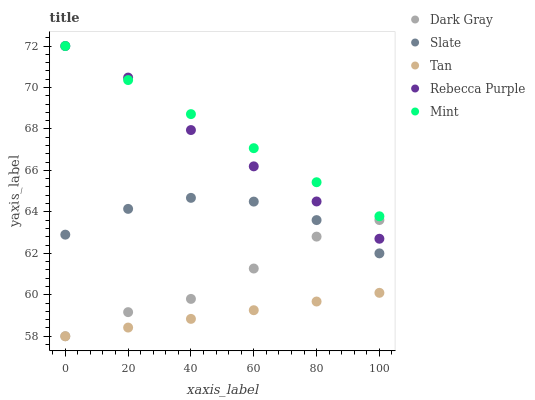Does Tan have the minimum area under the curve?
Answer yes or no. Yes. Does Mint have the maximum area under the curve?
Answer yes or no. Yes. Does Slate have the minimum area under the curve?
Answer yes or no. No. Does Slate have the maximum area under the curve?
Answer yes or no. No. Is Tan the smoothest?
Answer yes or no. Yes. Is Slate the roughest?
Answer yes or no. Yes. Is Mint the smoothest?
Answer yes or no. No. Is Mint the roughest?
Answer yes or no. No. Does Dark Gray have the lowest value?
Answer yes or no. Yes. Does Slate have the lowest value?
Answer yes or no. No. Does Rebecca Purple have the highest value?
Answer yes or no. Yes. Does Slate have the highest value?
Answer yes or no. No. Is Tan less than Mint?
Answer yes or no. Yes. Is Rebecca Purple greater than Tan?
Answer yes or no. Yes. Does Tan intersect Dark Gray?
Answer yes or no. Yes. Is Tan less than Dark Gray?
Answer yes or no. No. Is Tan greater than Dark Gray?
Answer yes or no. No. Does Tan intersect Mint?
Answer yes or no. No. 